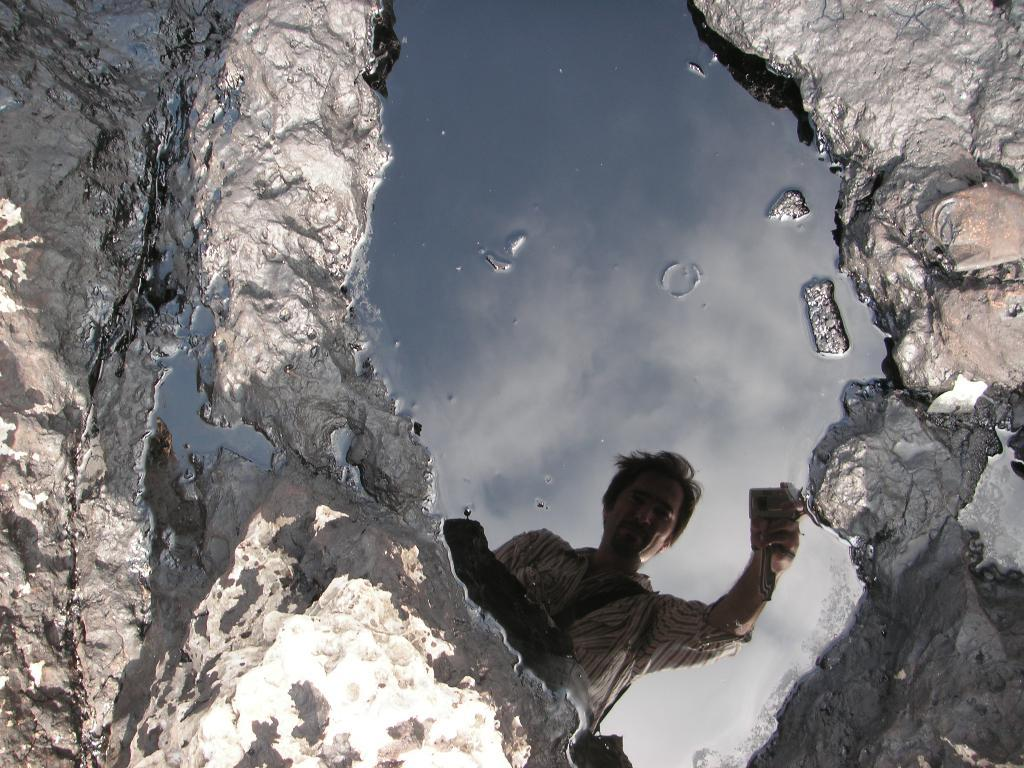What is visible in the image? There is water visible in the image. Can you describe what is happening in the water? There is a reflection of a person in the water. What time of day is it based on the hour shown in the image? There is no hour visible in the image, so it cannot be determined from the image. 